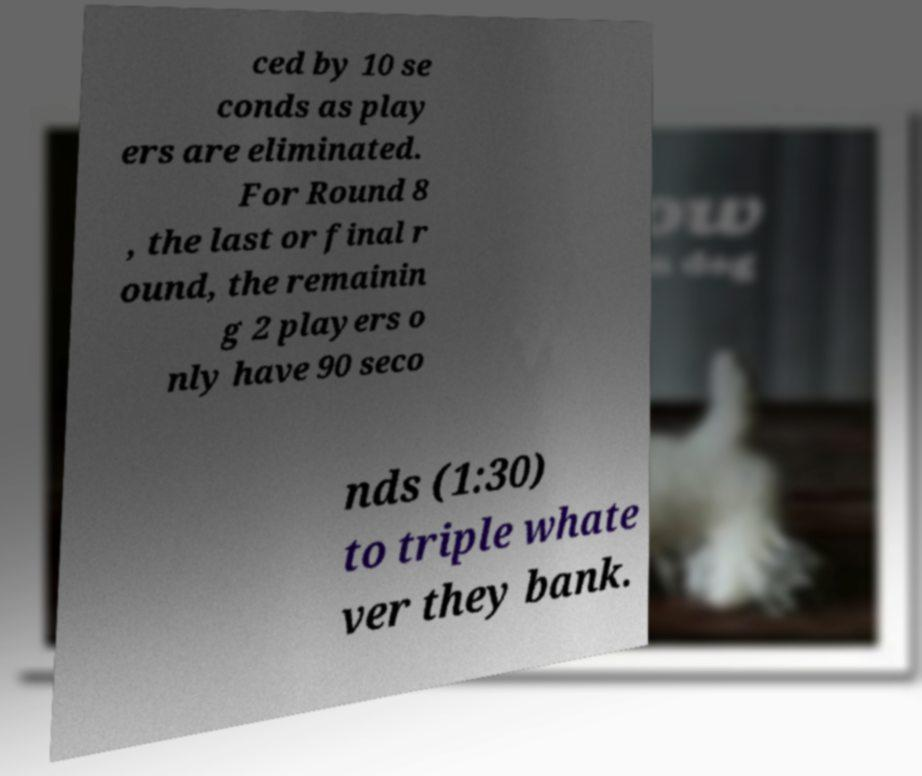There's text embedded in this image that I need extracted. Can you transcribe it verbatim? ced by 10 se conds as play ers are eliminated. For Round 8 , the last or final r ound, the remainin g 2 players o nly have 90 seco nds (1:30) to triple whate ver they bank. 